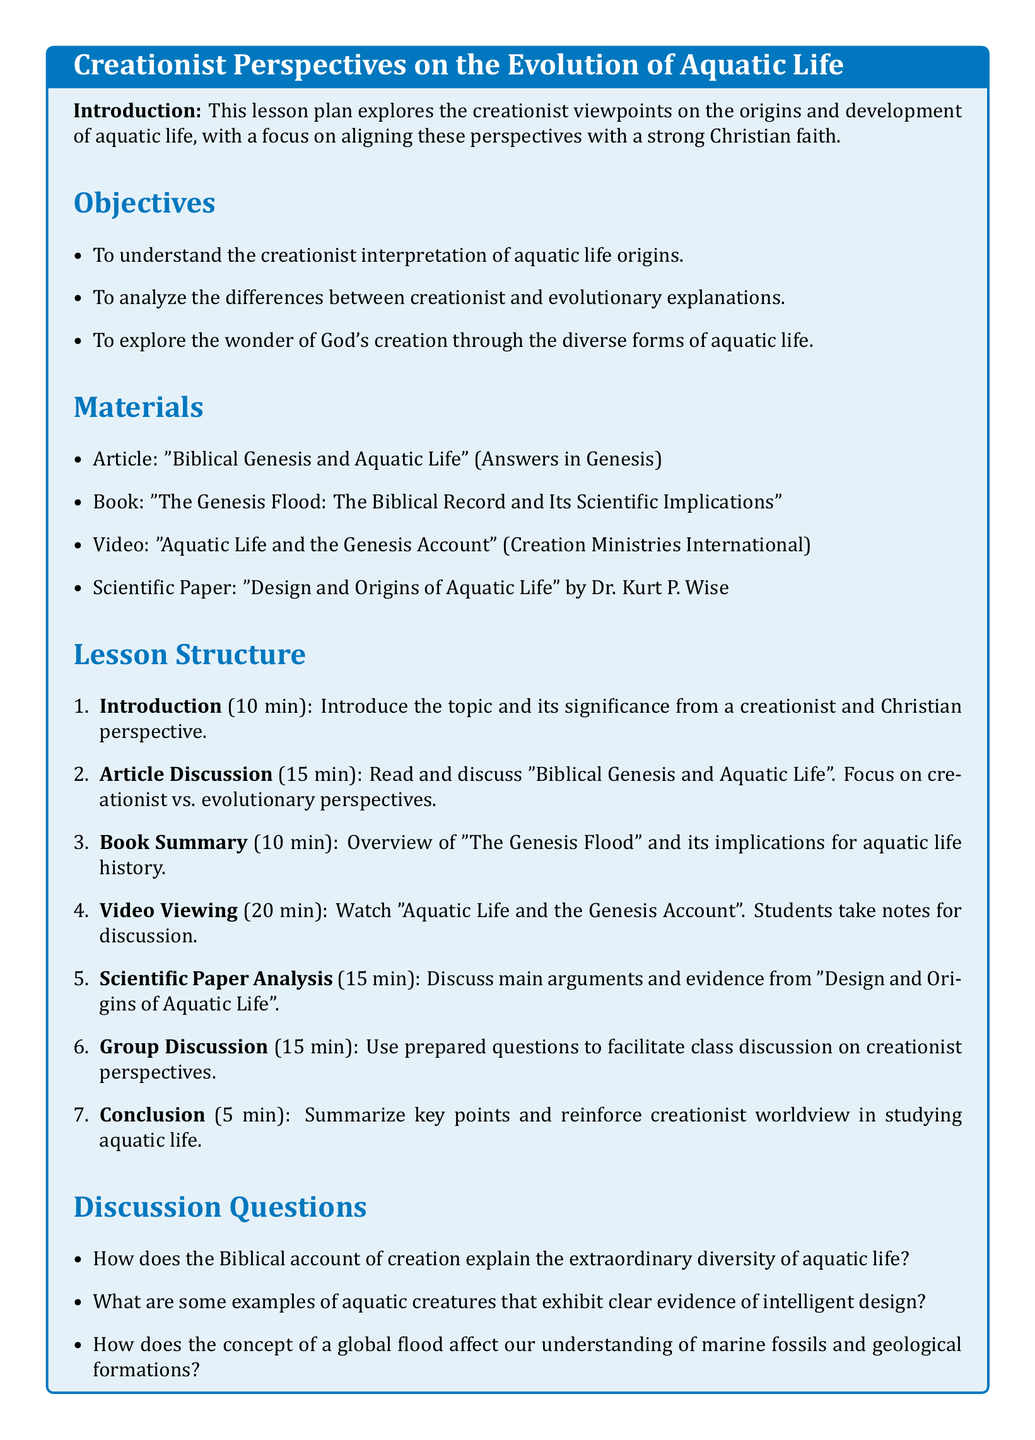What is the title of the lesson plan? The title is located at the top of the document within the tcolorbox.
Answer: Creationist Perspectives on the Evolution of Aquatic Life How many minutes is allocated for the introduction? The introduction section of the lesson structure specifies the time allotted for that activity.
Answer: 10 min What is the main purpose of the lesson plan? The objectives list the main purpose of the lesson plan, highlighting the key focus areas.
Answer: To understand the creationist interpretation of aquatic life origins Which article is mentioned as a material? The materials section lists the article to be discussed in the lesson.
Answer: "Biblical Genesis and Aquatic Life" How long is the video viewing segment planned for? The lesson structure specifies the amount of time dedicated to watching the video.
Answer: 20 min What type of paper is authored by Dr. Kurt P. Wise? The materials section identifies the type of document written by Dr. Kurt P. Wise.
Answer: Scientific Paper What is one example of a discussion question from the document? The discussion questions section lists various questions prepared for class discussion.
Answer: How does the Biblical account of creation explain the extraordinary diversity of aquatic life? How many minutes are devoted to the group discussion? The lesson structure outlines the time set aside for group discussions among students.
Answer: 15 min 